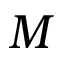Convert formula to latex. <formula><loc_0><loc_0><loc_500><loc_500>M</formula> 